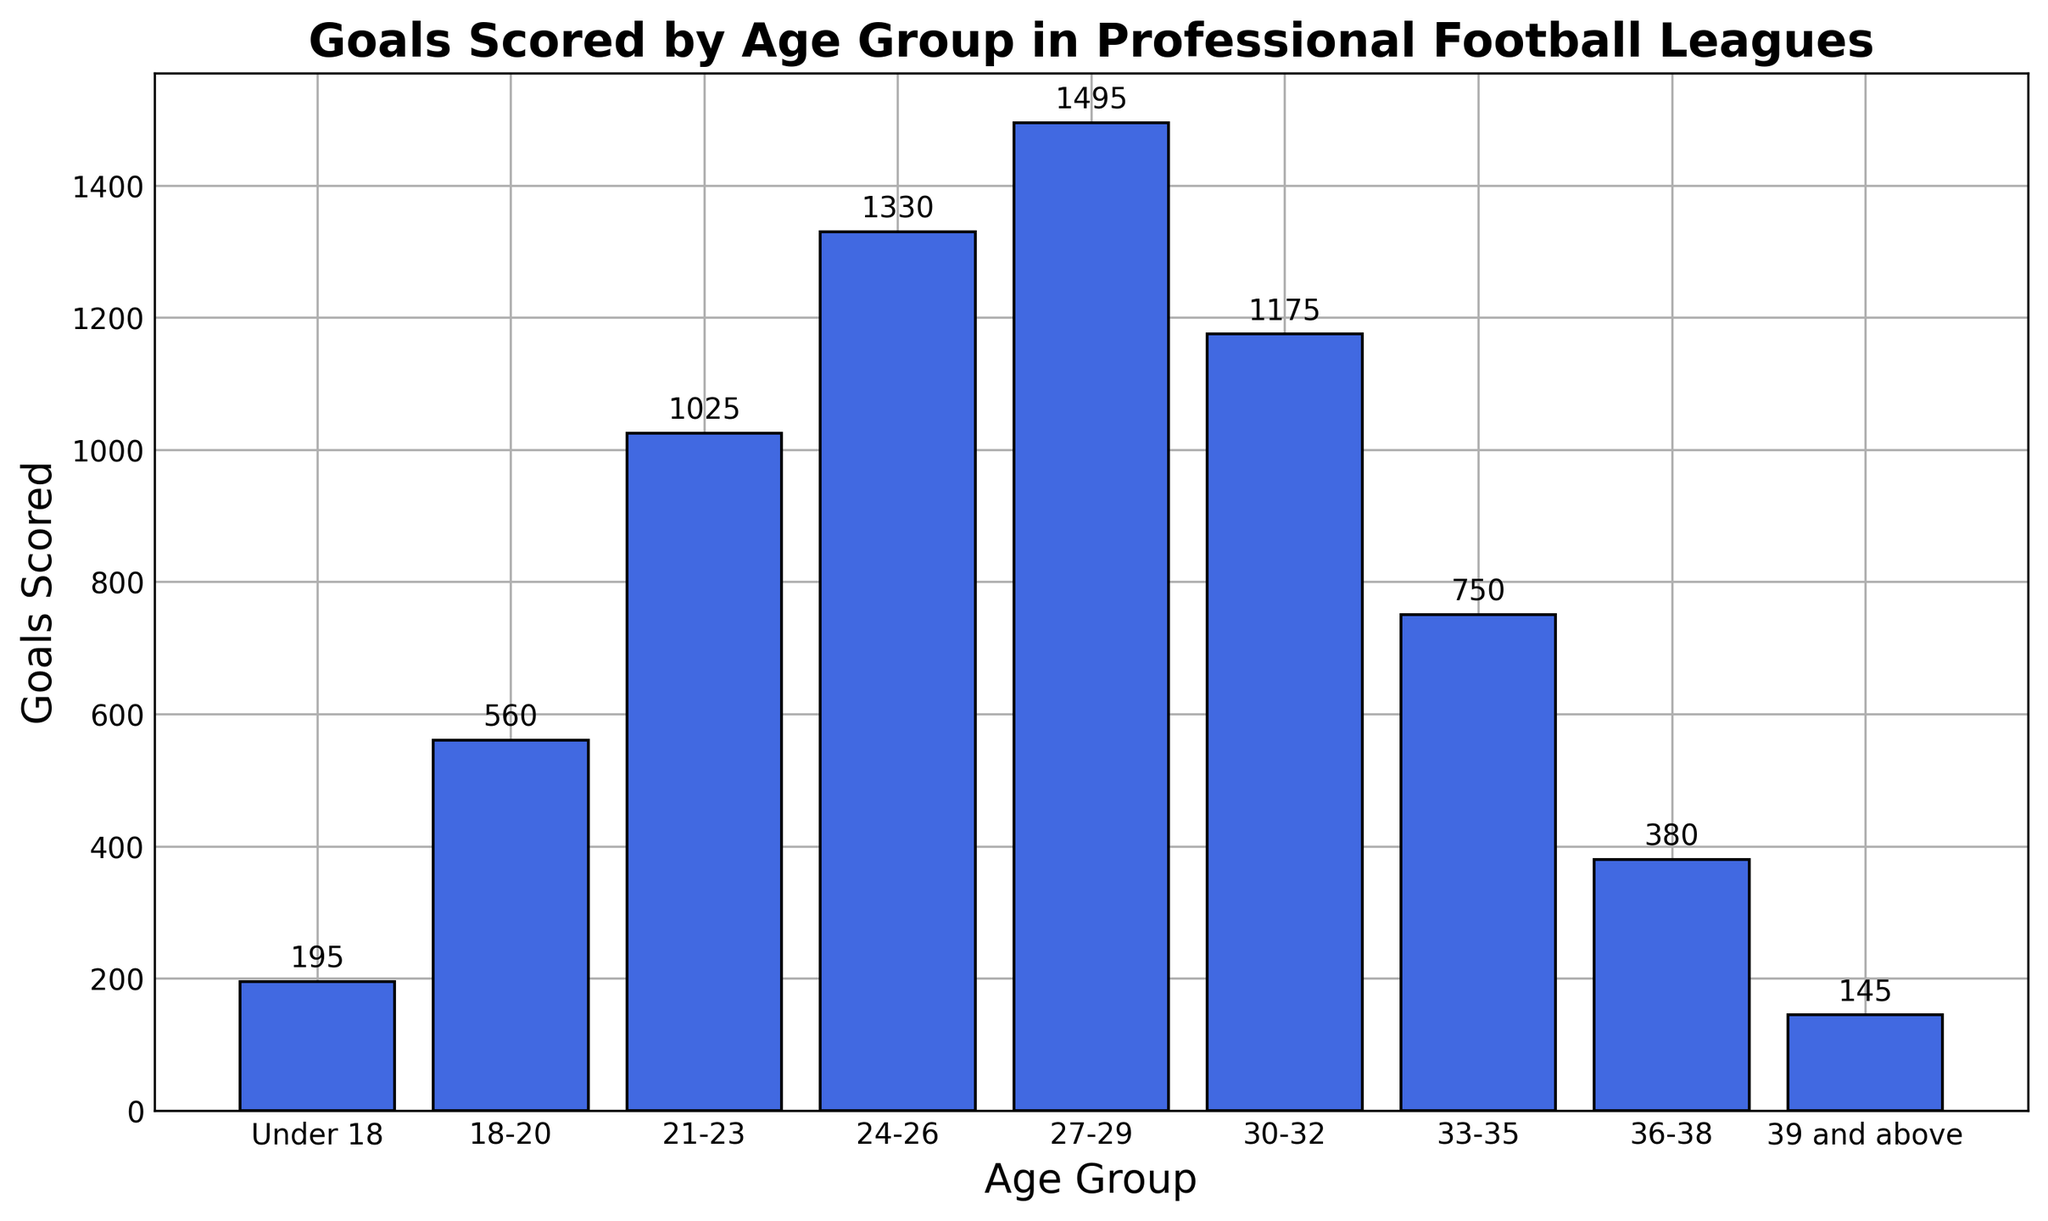Which age group has scored the most goals? The age group with the tallest bar represents the highest number of goals scored. The 27-29 age group has the highest bar, indicating the most goals scored.
Answer: 27-29 Which age group has scored the least goals? The age group with the shortest bar represents the smallest number of goals scored. The 39 and above age group has the shortest bar.
Answer: 39 and above What is the total number of goals scored by the Under 18 and 39 and above age groups combined? Sum the goals scored by the Under 18 group and the 39 and above group: 195 (Under 18) + 145 (39 and above) = 340
Answer: 340 How many more goals did the 27-29 age group score compared to the 33-35 age group? Subtract the goals scored by the 33-35 age group from the goals scored by the 27-29 age group: 1495 - 750 = 745
Answer: 745 What is the average number of goals scored by the age groups from 18 to 29? First, sum the goals scored by the 18-20, 21-23, 24-26, and 27-29 age groups: 560 + 1025 + 1330 + 1495 = 4410. Then, divide by the number of age groups, which is 4. 4410 / 4 = 1102.5
Answer: 1102.5 Which age group scored 1175 goals? Identify the bar with the height labeled as 1175. The age group corresponding to this bar is the 30-32 age group.
Answer: 30-32 How many goals were scored by players aged 33-35 and 36-38 combined? Sum the goals scored by the 33-35 and 36-38 age groups: 750 + 380 = 1130
Answer: 1130 What is the difference in goals scored between the 24-26 and 30-32 age groups? Subtract the goals scored by the 30-32 age group from the goals scored by the 24-26 age group: 1330 - 1175 = 155
Answer: 155 Which age group has a higher total of goals scored: Under 18 or 36-38? Compare the goals scored by the Under 18 group and the 36-38 group. The Under 18 group scored 195 goals, and the 36-38 group scored 380 goals.
Answer: 36-38 How many goals in total have been scored by players 30 years and older? Sum the goals scored by the age groups 30-32, 33-35, 36-38, and 39 and above: 1175 + 750 + 380 + 145 = 2450
Answer: 2450 